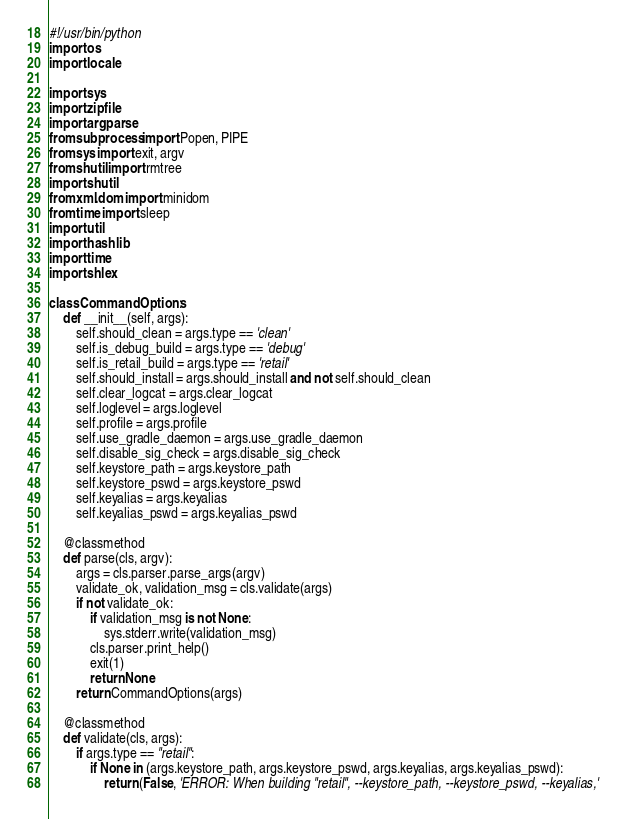<code> <loc_0><loc_0><loc_500><loc_500><_Python_>#!/usr/bin/python
import os
import locale

import sys
import zipfile
import argparse
from subprocess import Popen, PIPE
from sys import exit, argv
from shutil import rmtree
import shutil
from xml.dom import minidom
from time import sleep
import util
import hashlib
import time
import shlex

class CommandOptions:
    def __init__(self, args):
        self.should_clean = args.type == 'clean'
        self.is_debug_build = args.type == 'debug'
        self.is_retail_build = args.type == 'retail'
        self.should_install = args.should_install and not self.should_clean
        self.clear_logcat = args.clear_logcat
        self.loglevel = args.loglevel
        self.profile = args.profile
        self.use_gradle_daemon = args.use_gradle_daemon
        self.disable_sig_check = args.disable_sig_check
        self.keystore_path = args.keystore_path
        self.keystore_pswd = args.keystore_pswd
        self.keyalias = args.keyalias
        self.keyalias_pswd = args.keyalias_pswd

    @classmethod
    def parse(cls, argv):
        args = cls.parser.parse_args(argv)
        validate_ok, validation_msg = cls.validate(args)
        if not validate_ok:
            if validation_msg is not None:
                sys.stderr.write(validation_msg)
            cls.parser.print_help()
            exit(1)
            return None
        return CommandOptions(args)

    @classmethod
    def validate(cls, args):
        if args.type == "retail":
            if None in (args.keystore_path, args.keystore_pswd, args.keyalias, args.keyalias_pswd):
                return (False, 'ERROR: When building "retail", --keystore_path, --keystore_pswd, --keyalias,'</code> 